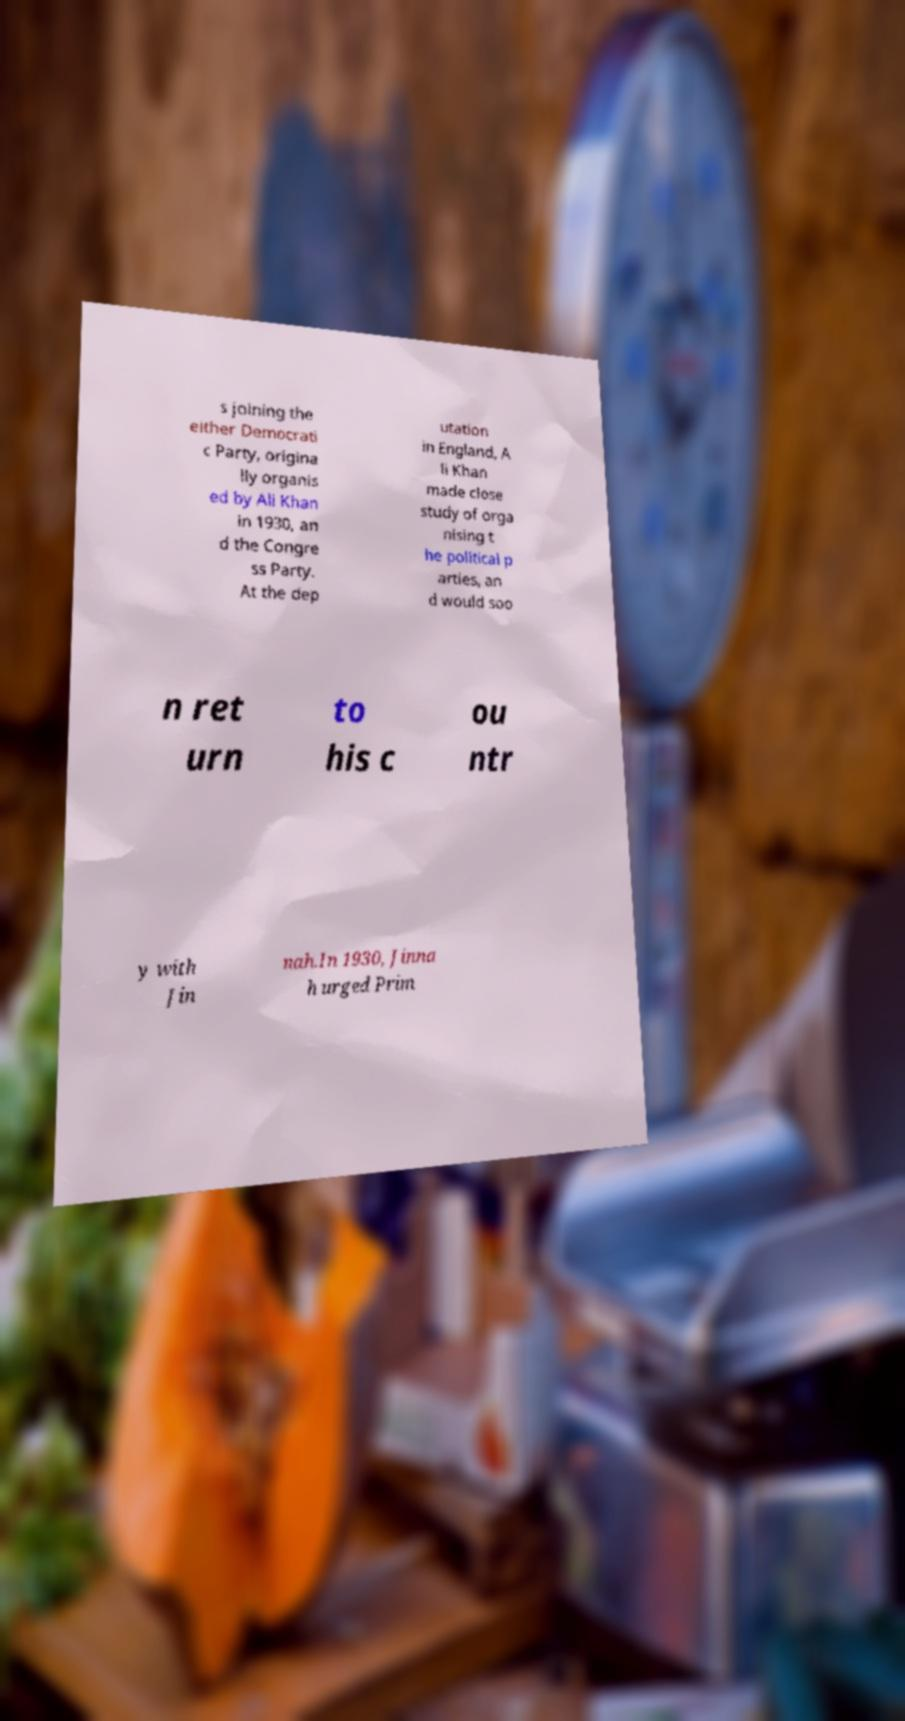I need the written content from this picture converted into text. Can you do that? s joining the either Democrati c Party, origina lly organis ed by Ali Khan in 1930, an d the Congre ss Party. At the dep utation in England, A li Khan made close study of orga nising t he political p arties, an d would soo n ret urn to his c ou ntr y with Jin nah.In 1930, Jinna h urged Prim 